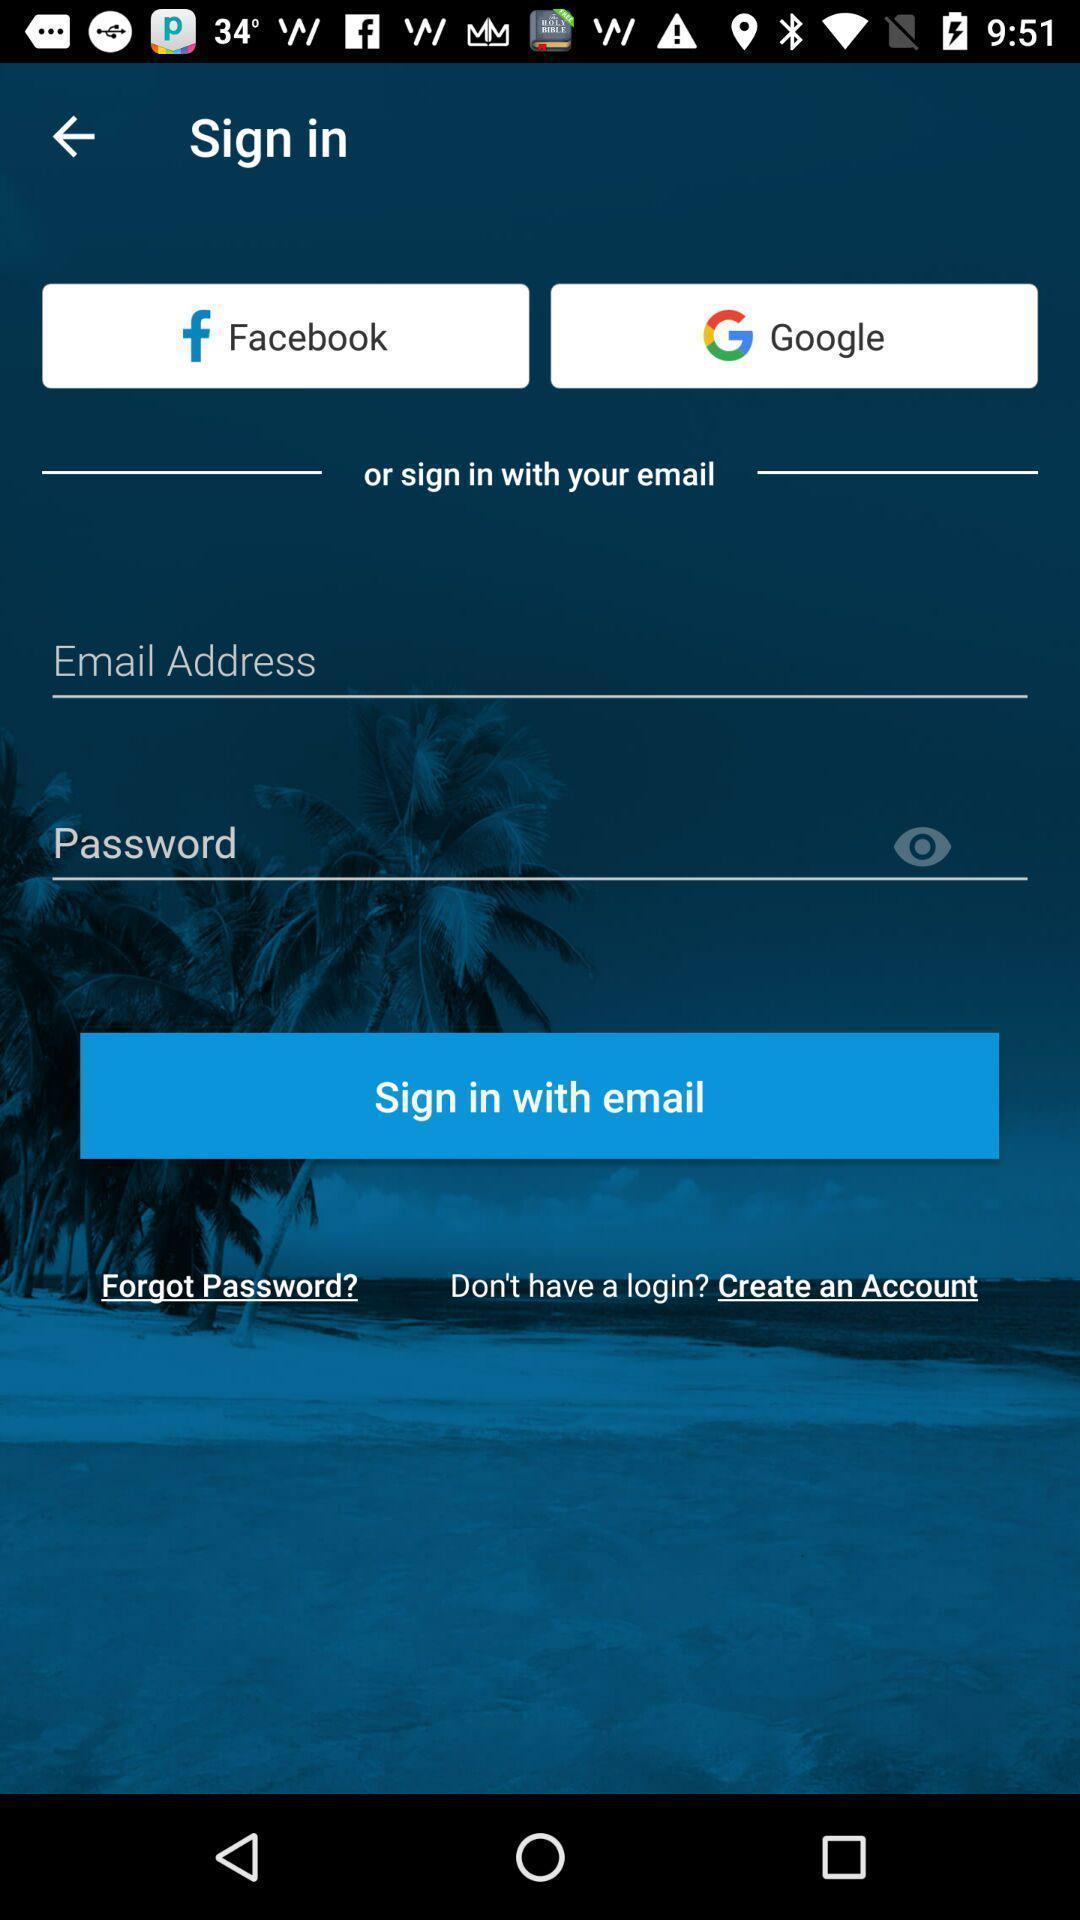Provide a detailed account of this screenshot. Sign in page of a social app. 